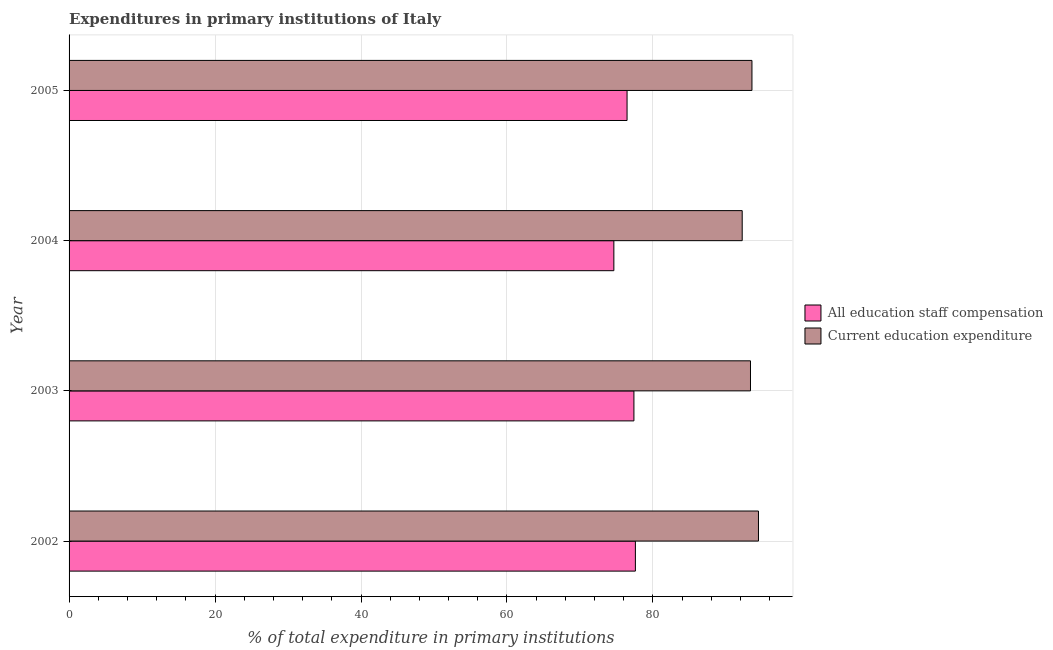How many different coloured bars are there?
Your answer should be compact. 2. How many groups of bars are there?
Your answer should be compact. 4. How many bars are there on the 1st tick from the bottom?
Give a very brief answer. 2. In how many cases, is the number of bars for a given year not equal to the number of legend labels?
Make the answer very short. 0. What is the expenditure in education in 2002?
Provide a succinct answer. 94.46. Across all years, what is the maximum expenditure in staff compensation?
Make the answer very short. 77.6. Across all years, what is the minimum expenditure in staff compensation?
Your response must be concise. 74.65. In which year was the expenditure in staff compensation maximum?
Make the answer very short. 2002. In which year was the expenditure in staff compensation minimum?
Make the answer very short. 2004. What is the total expenditure in staff compensation in the graph?
Give a very brief answer. 306.1. What is the difference between the expenditure in staff compensation in 2003 and that in 2004?
Ensure brevity in your answer.  2.75. What is the difference between the expenditure in education in 2002 and the expenditure in staff compensation in 2005?
Your answer should be very brief. 18.01. What is the average expenditure in education per year?
Provide a short and direct response. 93.41. In the year 2005, what is the difference between the expenditure in education and expenditure in staff compensation?
Your response must be concise. 17.11. Is the difference between the expenditure in staff compensation in 2004 and 2005 greater than the difference between the expenditure in education in 2004 and 2005?
Provide a succinct answer. No. What is the difference between the highest and the second highest expenditure in staff compensation?
Give a very brief answer. 0.2. What is the difference between the highest and the lowest expenditure in education?
Keep it short and to the point. 2.23. In how many years, is the expenditure in staff compensation greater than the average expenditure in staff compensation taken over all years?
Ensure brevity in your answer.  2. Is the sum of the expenditure in staff compensation in 2002 and 2004 greater than the maximum expenditure in education across all years?
Offer a very short reply. Yes. What does the 1st bar from the top in 2003 represents?
Make the answer very short. Current education expenditure. What does the 2nd bar from the bottom in 2002 represents?
Provide a short and direct response. Current education expenditure. How many years are there in the graph?
Your answer should be compact. 4. What is the difference between two consecutive major ticks on the X-axis?
Your answer should be very brief. 20. Are the values on the major ticks of X-axis written in scientific E-notation?
Give a very brief answer. No. Does the graph contain grids?
Keep it short and to the point. Yes. Where does the legend appear in the graph?
Make the answer very short. Center right. What is the title of the graph?
Provide a succinct answer. Expenditures in primary institutions of Italy. What is the label or title of the X-axis?
Make the answer very short. % of total expenditure in primary institutions. What is the % of total expenditure in primary institutions in All education staff compensation in 2002?
Ensure brevity in your answer.  77.6. What is the % of total expenditure in primary institutions of Current education expenditure in 2002?
Your answer should be compact. 94.46. What is the % of total expenditure in primary institutions in All education staff compensation in 2003?
Offer a very short reply. 77.4. What is the % of total expenditure in primary institutions of Current education expenditure in 2003?
Offer a very short reply. 93.37. What is the % of total expenditure in primary institutions of All education staff compensation in 2004?
Offer a very short reply. 74.65. What is the % of total expenditure in primary institutions of Current education expenditure in 2004?
Your answer should be very brief. 92.23. What is the % of total expenditure in primary institutions of All education staff compensation in 2005?
Offer a terse response. 76.46. What is the % of total expenditure in primary institutions of Current education expenditure in 2005?
Make the answer very short. 93.57. Across all years, what is the maximum % of total expenditure in primary institutions of All education staff compensation?
Your answer should be compact. 77.6. Across all years, what is the maximum % of total expenditure in primary institutions of Current education expenditure?
Your response must be concise. 94.46. Across all years, what is the minimum % of total expenditure in primary institutions in All education staff compensation?
Ensure brevity in your answer.  74.65. Across all years, what is the minimum % of total expenditure in primary institutions of Current education expenditure?
Offer a very short reply. 92.23. What is the total % of total expenditure in primary institutions of All education staff compensation in the graph?
Provide a succinct answer. 306.1. What is the total % of total expenditure in primary institutions of Current education expenditure in the graph?
Your answer should be very brief. 373.64. What is the difference between the % of total expenditure in primary institutions in All education staff compensation in 2002 and that in 2003?
Keep it short and to the point. 0.2. What is the difference between the % of total expenditure in primary institutions in Current education expenditure in 2002 and that in 2003?
Give a very brief answer. 1.09. What is the difference between the % of total expenditure in primary institutions in All education staff compensation in 2002 and that in 2004?
Ensure brevity in your answer.  2.95. What is the difference between the % of total expenditure in primary institutions of Current education expenditure in 2002 and that in 2004?
Make the answer very short. 2.23. What is the difference between the % of total expenditure in primary institutions in All education staff compensation in 2002 and that in 2005?
Keep it short and to the point. 1.14. What is the difference between the % of total expenditure in primary institutions in Current education expenditure in 2002 and that in 2005?
Give a very brief answer. 0.89. What is the difference between the % of total expenditure in primary institutions of All education staff compensation in 2003 and that in 2004?
Keep it short and to the point. 2.75. What is the difference between the % of total expenditure in primary institutions in Current education expenditure in 2003 and that in 2004?
Give a very brief answer. 1.14. What is the difference between the % of total expenditure in primary institutions in All education staff compensation in 2003 and that in 2005?
Your answer should be very brief. 0.94. What is the difference between the % of total expenditure in primary institutions of Current education expenditure in 2003 and that in 2005?
Your answer should be compact. -0.2. What is the difference between the % of total expenditure in primary institutions in All education staff compensation in 2004 and that in 2005?
Ensure brevity in your answer.  -1.81. What is the difference between the % of total expenditure in primary institutions in Current education expenditure in 2004 and that in 2005?
Your answer should be very brief. -1.34. What is the difference between the % of total expenditure in primary institutions of All education staff compensation in 2002 and the % of total expenditure in primary institutions of Current education expenditure in 2003?
Ensure brevity in your answer.  -15.77. What is the difference between the % of total expenditure in primary institutions in All education staff compensation in 2002 and the % of total expenditure in primary institutions in Current education expenditure in 2004?
Your response must be concise. -14.64. What is the difference between the % of total expenditure in primary institutions of All education staff compensation in 2002 and the % of total expenditure in primary institutions of Current education expenditure in 2005?
Your answer should be very brief. -15.97. What is the difference between the % of total expenditure in primary institutions in All education staff compensation in 2003 and the % of total expenditure in primary institutions in Current education expenditure in 2004?
Your answer should be compact. -14.84. What is the difference between the % of total expenditure in primary institutions of All education staff compensation in 2003 and the % of total expenditure in primary institutions of Current education expenditure in 2005?
Make the answer very short. -16.17. What is the difference between the % of total expenditure in primary institutions in All education staff compensation in 2004 and the % of total expenditure in primary institutions in Current education expenditure in 2005?
Provide a short and direct response. -18.92. What is the average % of total expenditure in primary institutions of All education staff compensation per year?
Give a very brief answer. 76.53. What is the average % of total expenditure in primary institutions in Current education expenditure per year?
Your response must be concise. 93.41. In the year 2002, what is the difference between the % of total expenditure in primary institutions of All education staff compensation and % of total expenditure in primary institutions of Current education expenditure?
Your response must be concise. -16.87. In the year 2003, what is the difference between the % of total expenditure in primary institutions of All education staff compensation and % of total expenditure in primary institutions of Current education expenditure?
Ensure brevity in your answer.  -15.97. In the year 2004, what is the difference between the % of total expenditure in primary institutions in All education staff compensation and % of total expenditure in primary institutions in Current education expenditure?
Provide a succinct answer. -17.58. In the year 2005, what is the difference between the % of total expenditure in primary institutions in All education staff compensation and % of total expenditure in primary institutions in Current education expenditure?
Ensure brevity in your answer.  -17.11. What is the ratio of the % of total expenditure in primary institutions in Current education expenditure in 2002 to that in 2003?
Provide a succinct answer. 1.01. What is the ratio of the % of total expenditure in primary institutions of All education staff compensation in 2002 to that in 2004?
Your answer should be compact. 1.04. What is the ratio of the % of total expenditure in primary institutions of Current education expenditure in 2002 to that in 2004?
Make the answer very short. 1.02. What is the ratio of the % of total expenditure in primary institutions of All education staff compensation in 2002 to that in 2005?
Ensure brevity in your answer.  1.01. What is the ratio of the % of total expenditure in primary institutions of Current education expenditure in 2002 to that in 2005?
Make the answer very short. 1.01. What is the ratio of the % of total expenditure in primary institutions of All education staff compensation in 2003 to that in 2004?
Give a very brief answer. 1.04. What is the ratio of the % of total expenditure in primary institutions in Current education expenditure in 2003 to that in 2004?
Offer a terse response. 1.01. What is the ratio of the % of total expenditure in primary institutions in All education staff compensation in 2003 to that in 2005?
Provide a short and direct response. 1.01. What is the ratio of the % of total expenditure in primary institutions of All education staff compensation in 2004 to that in 2005?
Your answer should be compact. 0.98. What is the ratio of the % of total expenditure in primary institutions of Current education expenditure in 2004 to that in 2005?
Ensure brevity in your answer.  0.99. What is the difference between the highest and the second highest % of total expenditure in primary institutions of All education staff compensation?
Offer a terse response. 0.2. What is the difference between the highest and the second highest % of total expenditure in primary institutions in Current education expenditure?
Give a very brief answer. 0.89. What is the difference between the highest and the lowest % of total expenditure in primary institutions of All education staff compensation?
Keep it short and to the point. 2.95. What is the difference between the highest and the lowest % of total expenditure in primary institutions in Current education expenditure?
Offer a terse response. 2.23. 